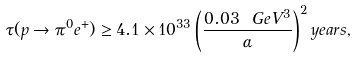<formula> <loc_0><loc_0><loc_500><loc_500>\tau ( p \rightarrow \pi ^ { 0 } e ^ { + } ) \geq 4 . 1 \times 1 0 ^ { 3 3 } \left ( \frac { 0 . 0 3 \ G e V ^ { 3 } } { \alpha } \right ) ^ { 2 } y e a r s ,</formula> 